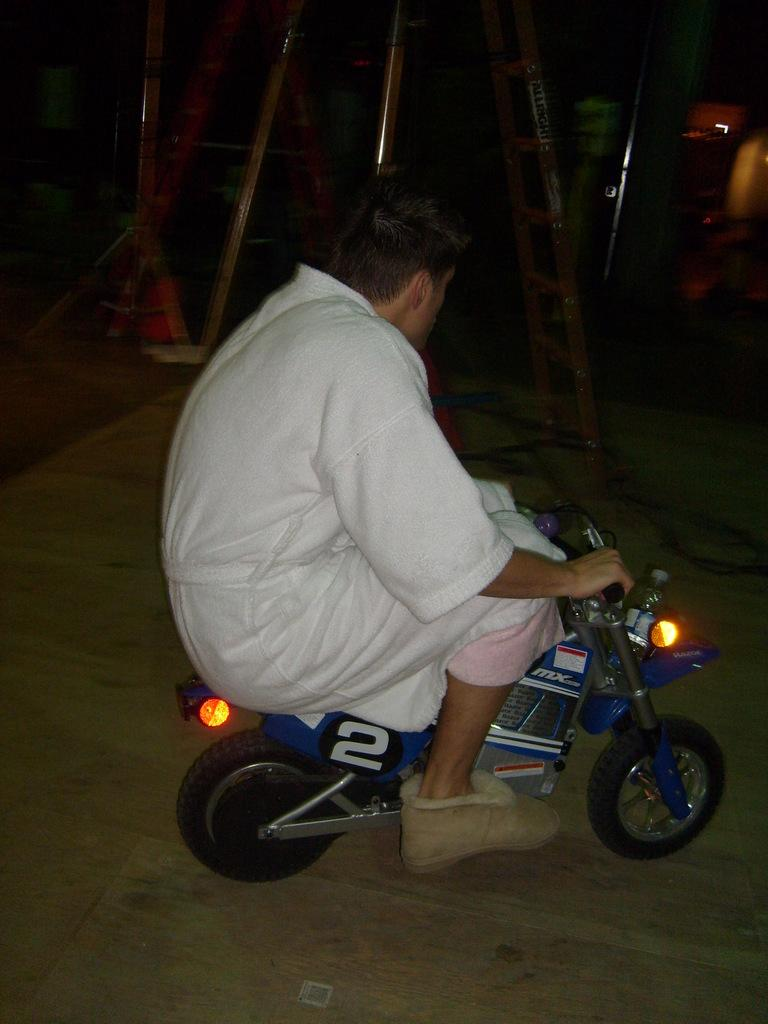Who is the main subject in the image? There is a person in the image. What is the person doing in the image? The person is driving a bike. What book is the scarecrow reading while sitting on the bike in the image? There is no scarecrow or book present in the image; it features a person driving a bike. 